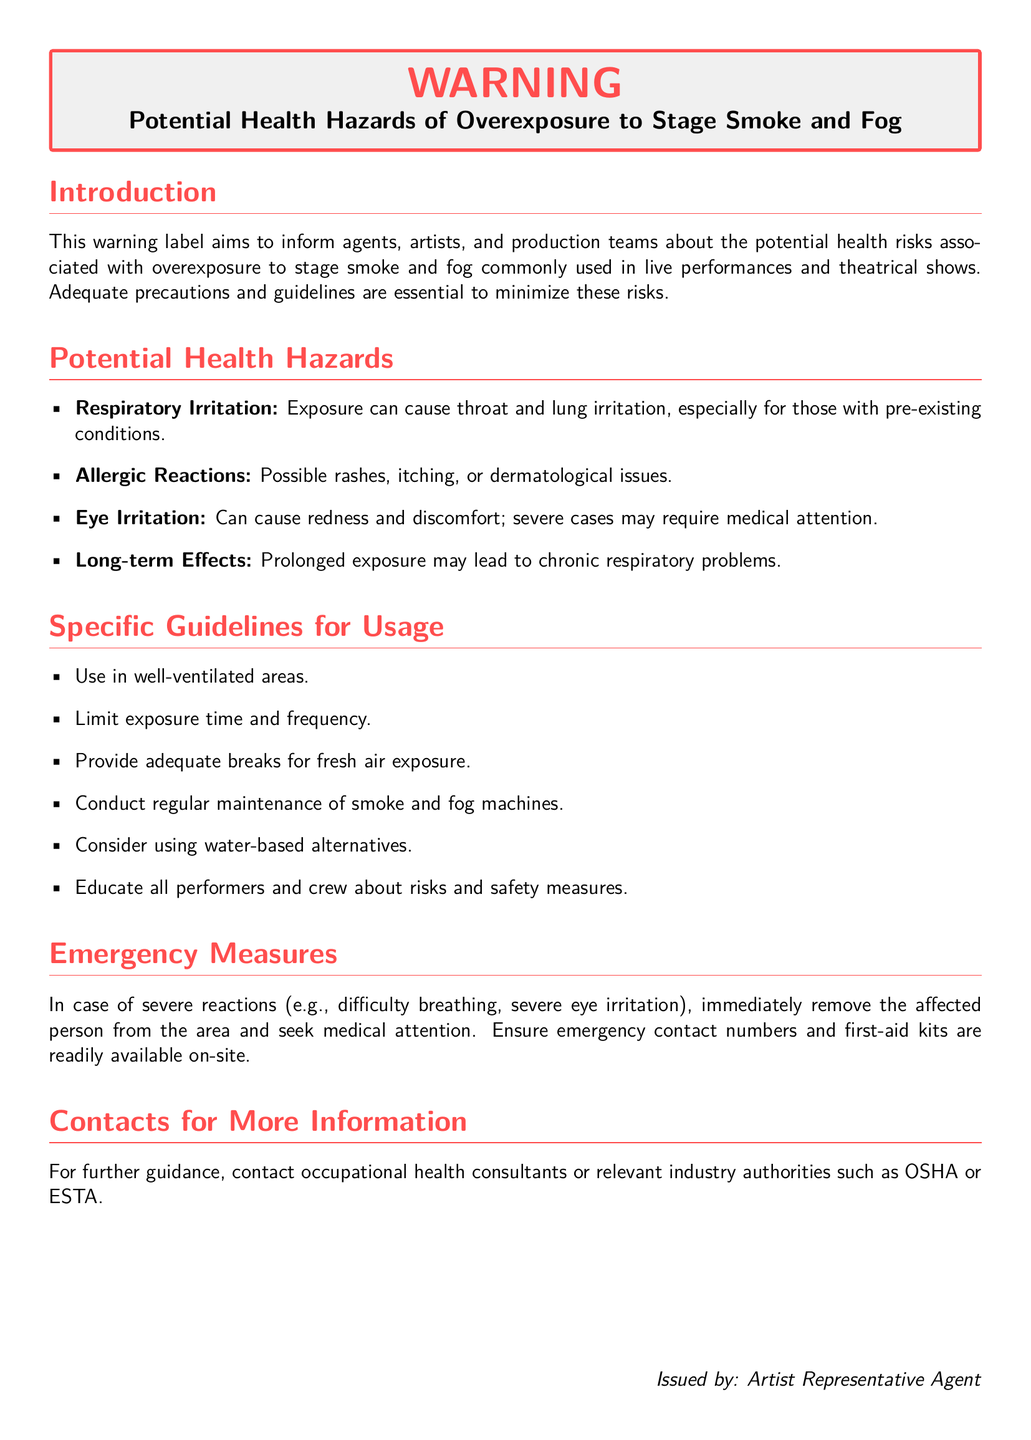What is the title of the warning document? The title of the warning document indicates the focus on potential health hazards related to stage smoke and fog.
Answer: Potential Health Hazards of Overexposure to Stage Smoke and Fog What can cause respiratory irritation? This refers to the substances identified in the document that can cause throat and lung issues.
Answer: Stage smoke and fog What should be done in case of severe reactions? This question addresses the emergency measures recommended in the document for severe reactions from exposure.
Answer: Seek medical attention What are water-based alternatives used for? This relates to the guidelines provided for safer practices related to smoke and fog usage.
Answer: Reducing health risks How many potential health hazards are listed? The number of health risks associated with overexposure is counted from the document.
Answer: Four What is one guideline for using stage smoke and fog? This question looks for specific instructions provided in the guidelines for users of smoke and fog.
Answer: Use in well-ventilated areas Who issued this warning? This identifies the authority or individual responsible for the warning label.
Answer: Artist Representative Agent What should be provided for fresh air exposure? This indicates what is necessary to mitigate the risks of exposure to smoke and fog.
Answer: Adequate breaks 